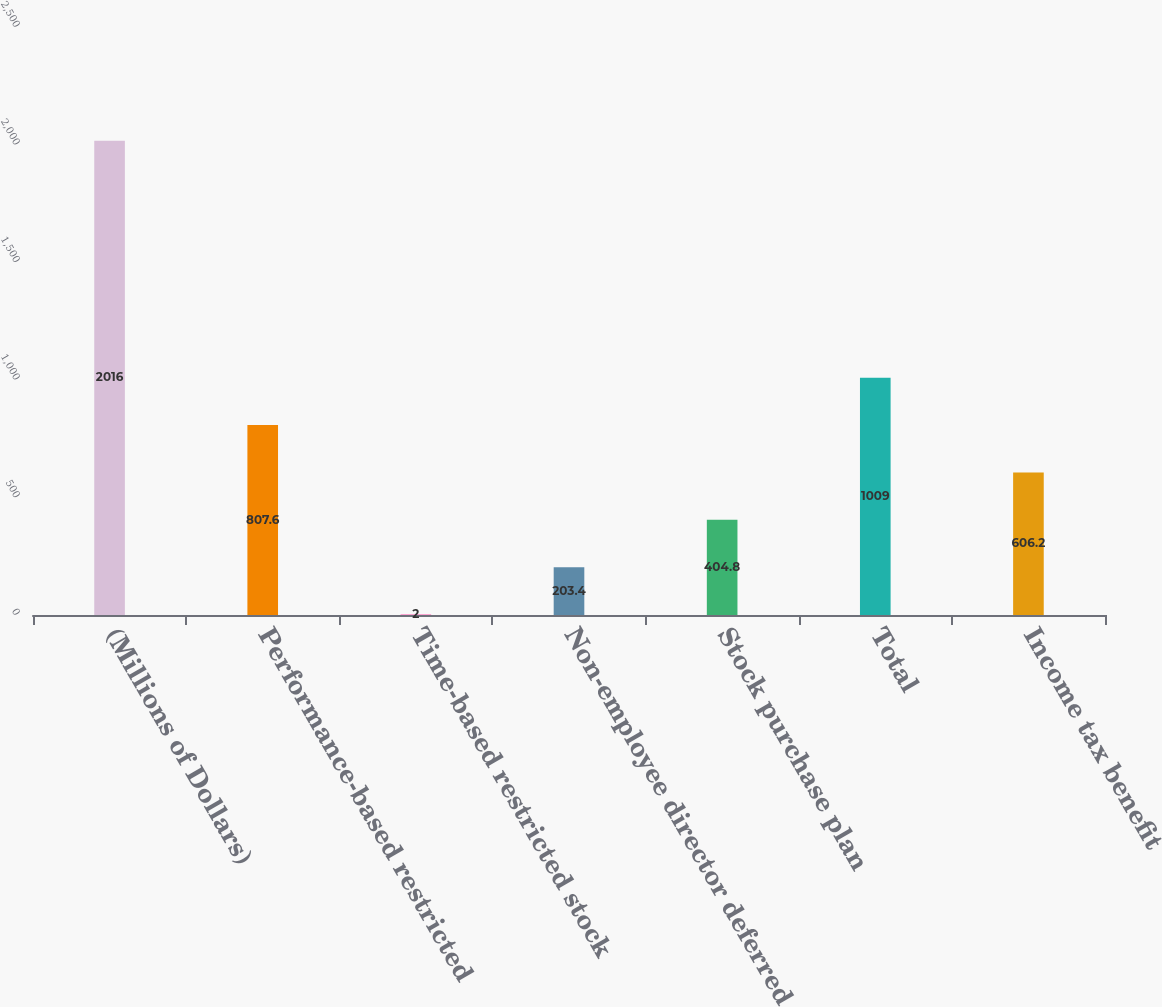<chart> <loc_0><loc_0><loc_500><loc_500><bar_chart><fcel>(Millions of Dollars)<fcel>Performance-based restricted<fcel>Time-based restricted stock<fcel>Non-employee director deferred<fcel>Stock purchase plan<fcel>Total<fcel>Income tax benefit<nl><fcel>2016<fcel>807.6<fcel>2<fcel>203.4<fcel>404.8<fcel>1009<fcel>606.2<nl></chart> 